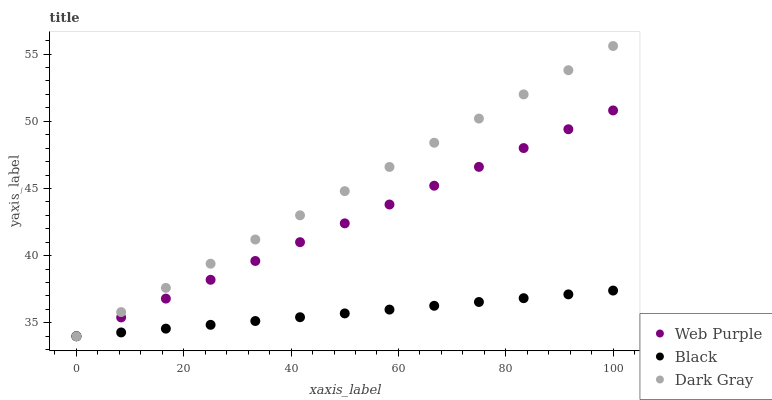Does Black have the minimum area under the curve?
Answer yes or no. Yes. Does Dark Gray have the maximum area under the curve?
Answer yes or no. Yes. Does Web Purple have the minimum area under the curve?
Answer yes or no. No. Does Web Purple have the maximum area under the curve?
Answer yes or no. No. Is Black the smoothest?
Answer yes or no. Yes. Is Web Purple the roughest?
Answer yes or no. Yes. Is Web Purple the smoothest?
Answer yes or no. No. Is Black the roughest?
Answer yes or no. No. Does Dark Gray have the lowest value?
Answer yes or no. Yes. Does Dark Gray have the highest value?
Answer yes or no. Yes. Does Web Purple have the highest value?
Answer yes or no. No. Does Web Purple intersect Dark Gray?
Answer yes or no. Yes. Is Web Purple less than Dark Gray?
Answer yes or no. No. Is Web Purple greater than Dark Gray?
Answer yes or no. No. 